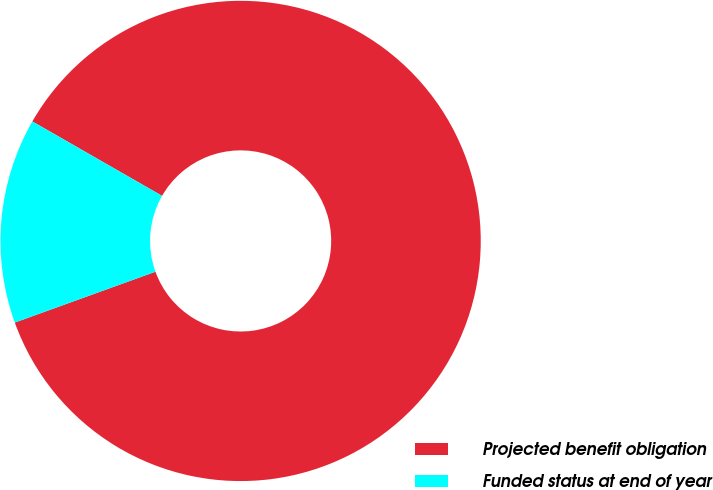Convert chart. <chart><loc_0><loc_0><loc_500><loc_500><pie_chart><fcel>Projected benefit obligation<fcel>Funded status at end of year<nl><fcel>86.19%<fcel>13.81%<nl></chart> 